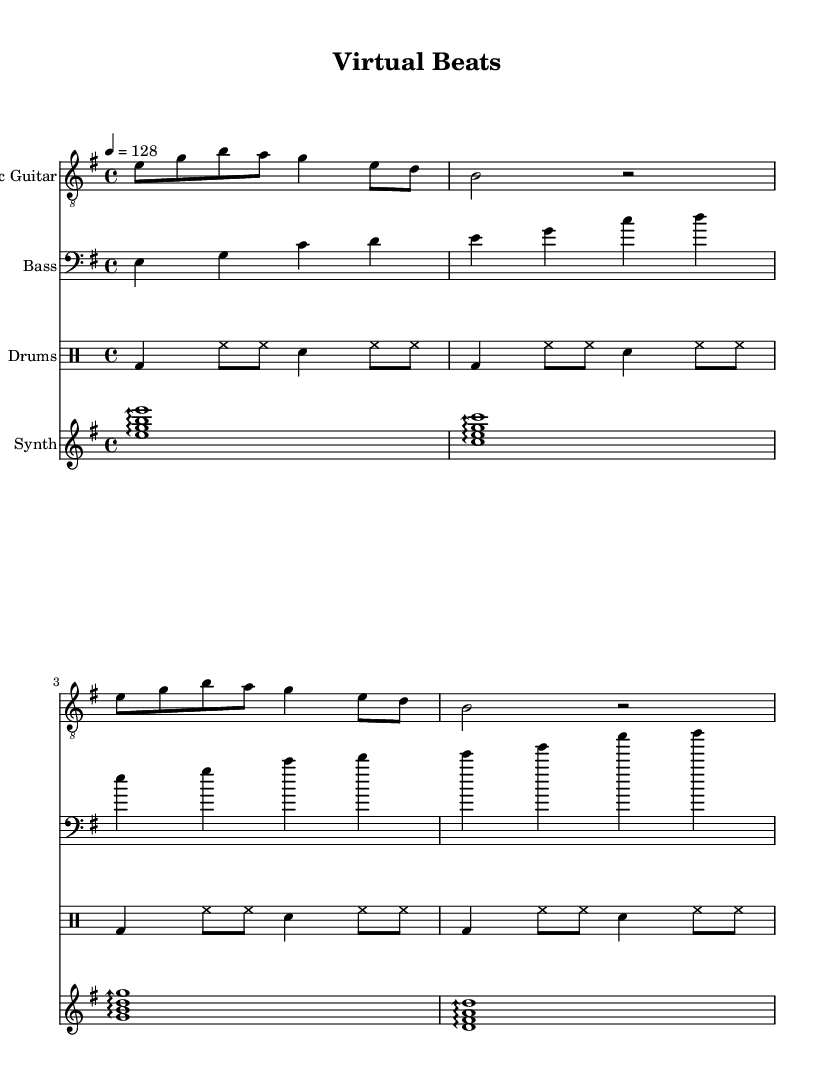What is the key signature of this music? The key signature is E minor, which has one sharp (F#). This can be identified by looking at the beginning of the staff, where the sharp is indicated.
Answer: E minor What is the time signature of this piece? The time signature is 4/4, which means there are four beats in each measure and the quarter note gets one beat. This is shown at the beginning of the score.
Answer: 4/4 What is the tempo indication for the piece? The tempo is marked at 128 beats per minute. This can be determined where the tempo marking is specified, indicating the speed at which the music should be played.
Answer: 128 How many measures are there in the drum part? There are four measures in the drum part. This can be counted by looking at how many groups of beats are shown in the drums section, each representing a measure.
Answer: 4 Which instrument plays the arpeggiated chords? The synthesizer plays the arpeggiated chords. This is indicated by the notation appearing in the staff labeled "Synth," which contains the arpeggio markings.
Answer: Synth How does the bass guitar part compare in rhythm to the electric guitar part? The bass guitar part has a steady rhythm, playing quarter notes, while the electric guitar has eighth and quarter notes, creating a contrast in rhythmic complexity. This can be understood by analyzing the note durations in both instruments.
Answer: Steady vs. complex What is the primary electronic feature utilized in this composition? The primary electronic feature is the use of synthesizer arpeggios. This is evident in the synthesizer part where the notes are played in an arpeggiated style, which is typical in modern rock fusion incorporating electronic elements.
Answer: Synthesizer arpeggios 